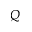<formula> <loc_0><loc_0><loc_500><loc_500>Q</formula> 